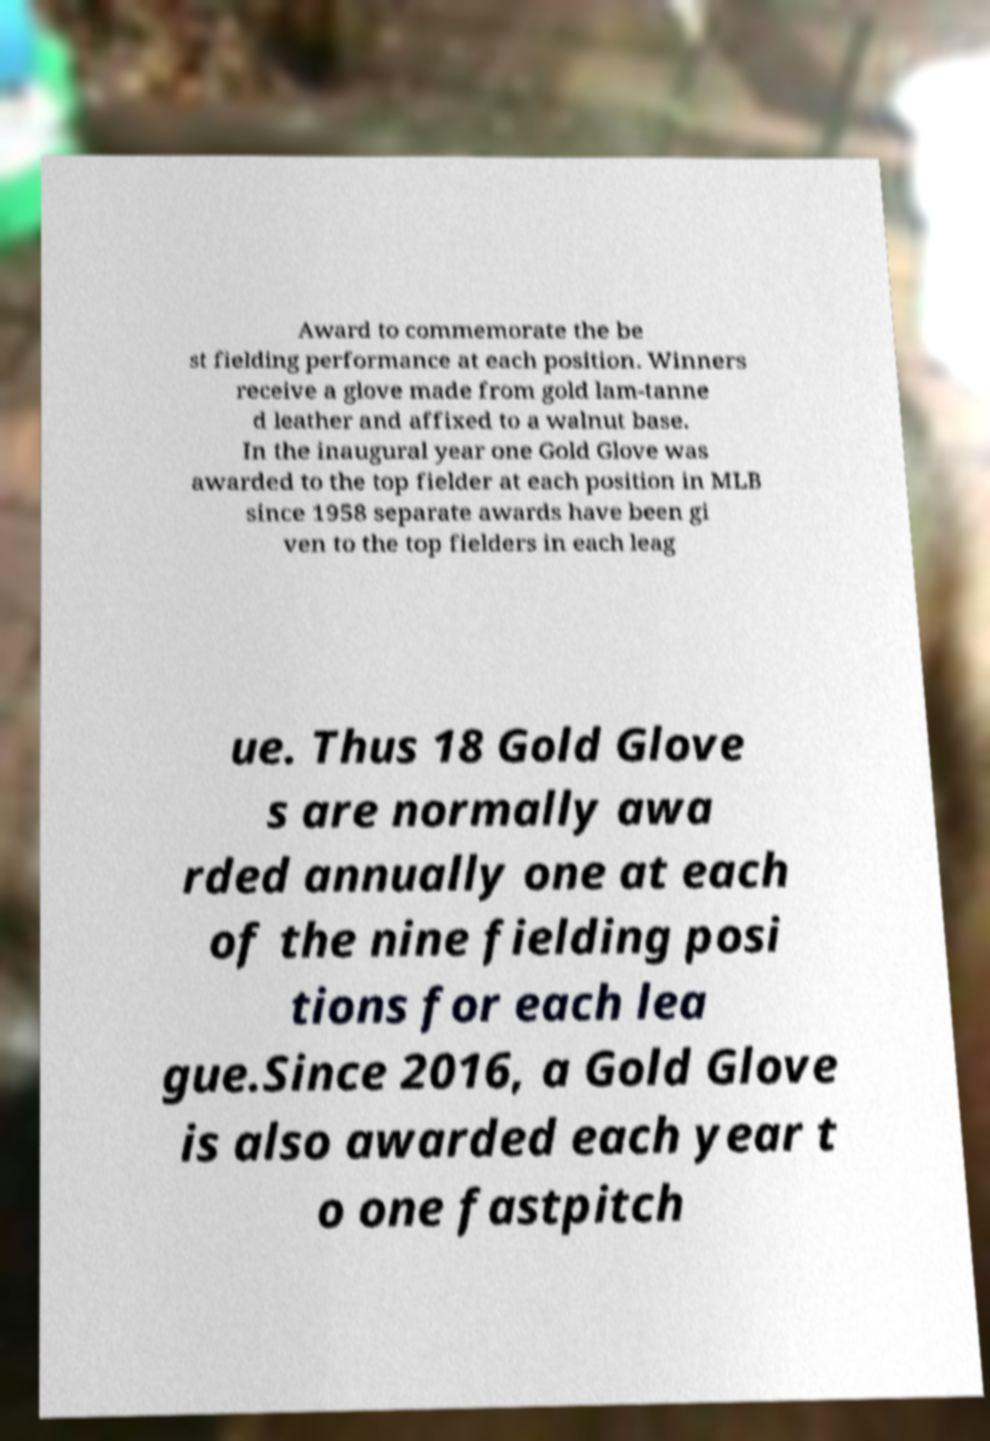For documentation purposes, I need the text within this image transcribed. Could you provide that? Award to commemorate the be st fielding performance at each position. Winners receive a glove made from gold lam-tanne d leather and affixed to a walnut base. In the inaugural year one Gold Glove was awarded to the top fielder at each position in MLB since 1958 separate awards have been gi ven to the top fielders in each leag ue. Thus 18 Gold Glove s are normally awa rded annually one at each of the nine fielding posi tions for each lea gue.Since 2016, a Gold Glove is also awarded each year t o one fastpitch 